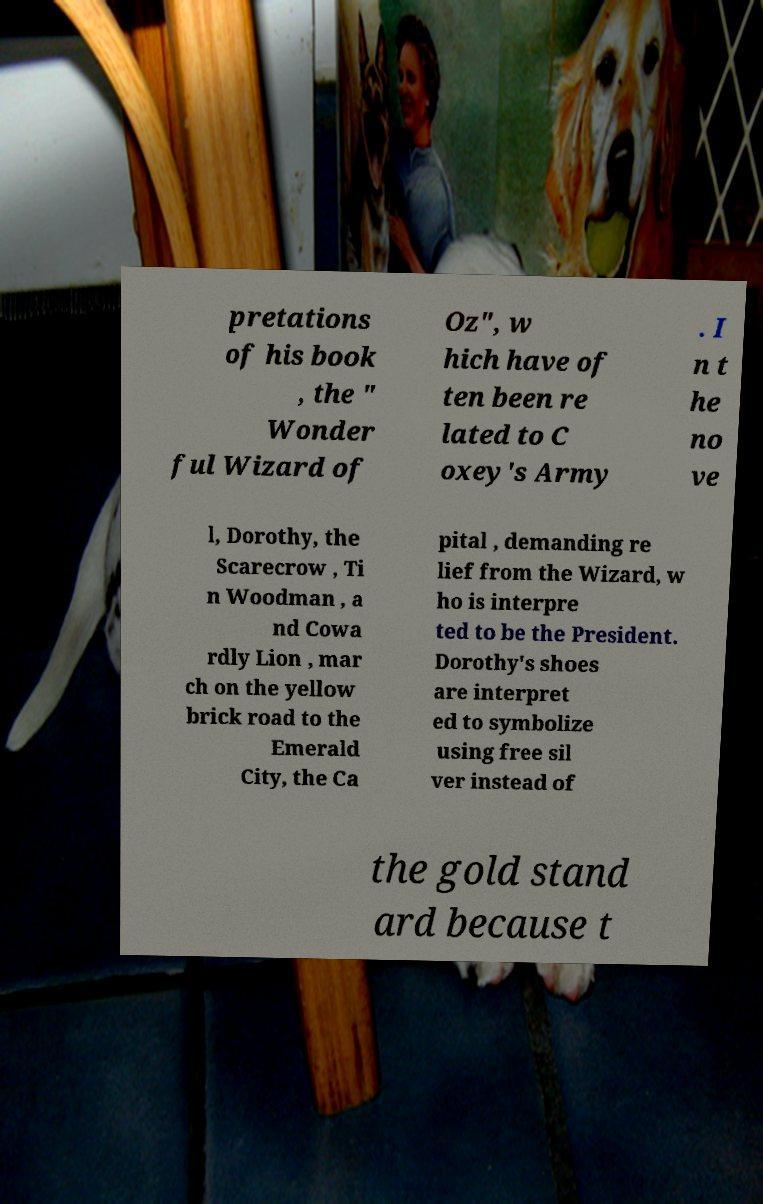Please read and relay the text visible in this image. What does it say? pretations of his book , the " Wonder ful Wizard of Oz", w hich have of ten been re lated to C oxey's Army . I n t he no ve l, Dorothy, the Scarecrow , Ti n Woodman , a nd Cowa rdly Lion , mar ch on the yellow brick road to the Emerald City, the Ca pital , demanding re lief from the Wizard, w ho is interpre ted to be the President. Dorothy's shoes are interpret ed to symbolize using free sil ver instead of the gold stand ard because t 